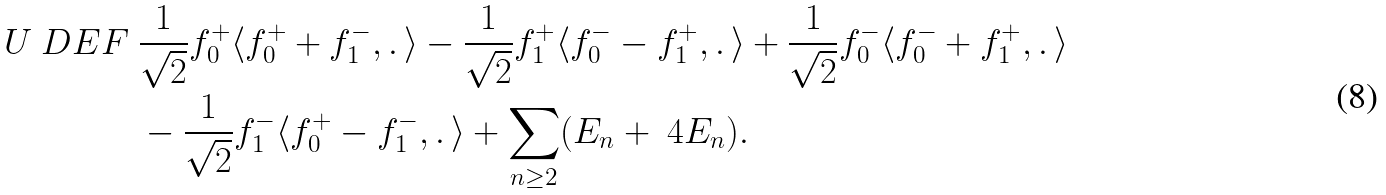<formula> <loc_0><loc_0><loc_500><loc_500>U \ D E F \ & \frac { 1 } { \sqrt { 2 } } f _ { 0 } ^ { + } \langle f _ { 0 } ^ { + } + f _ { 1 } ^ { - } , . \, \rangle - \frac { 1 } { \sqrt { 2 } } f _ { 1 } ^ { + } \langle f _ { 0 } ^ { - } - f _ { 1 } ^ { + } , . \, \rangle + \frac { 1 } { \sqrt { 2 } } f _ { 0 } ^ { - } \langle f _ { 0 } ^ { - } + f _ { 1 } ^ { + } , . \, \rangle \\ & - \frac { 1 } { \sqrt { 2 } } f _ { 1 } ^ { - } \langle f _ { 0 } ^ { + } - f _ { 1 } ^ { - } , . \, \rangle + \sum _ { n \geq 2 } ( E _ { n } + \ 4 { E _ { n } } ) .</formula> 